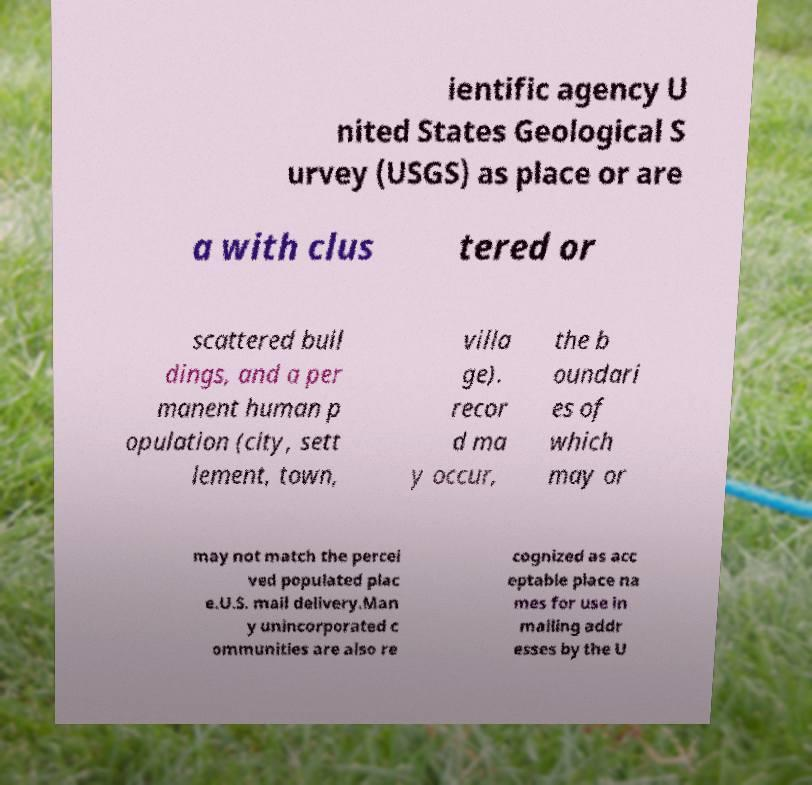There's text embedded in this image that I need extracted. Can you transcribe it verbatim? ientific agency U nited States Geological S urvey (USGS) as place or are a with clus tered or scattered buil dings, and a per manent human p opulation (city, sett lement, town, villa ge). recor d ma y occur, the b oundari es of which may or may not match the percei ved populated plac e.U.S. mail delivery.Man y unincorporated c ommunities are also re cognized as acc eptable place na mes for use in mailing addr esses by the U 